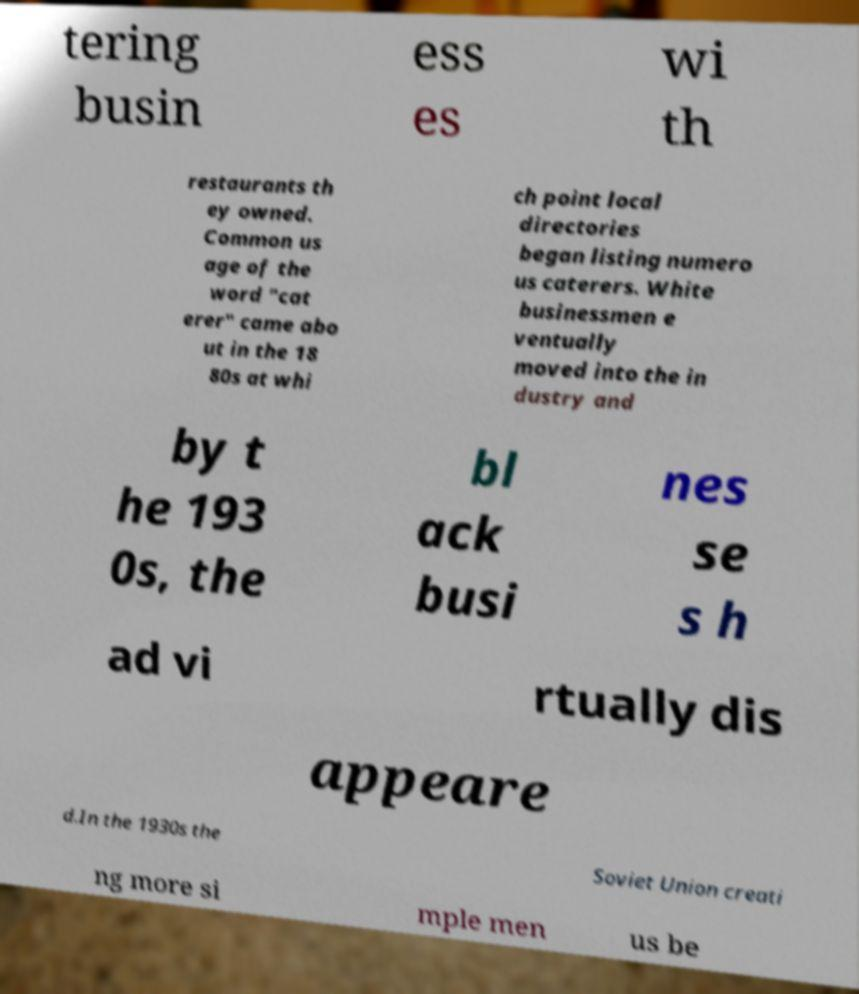Can you read and provide the text displayed in the image?This photo seems to have some interesting text. Can you extract and type it out for me? tering busin ess es wi th restaurants th ey owned. Common us age of the word "cat erer" came abo ut in the 18 80s at whi ch point local directories began listing numero us caterers. White businessmen e ventually moved into the in dustry and by t he 193 0s, the bl ack busi nes se s h ad vi rtually dis appeare d.In the 1930s the Soviet Union creati ng more si mple men us be 